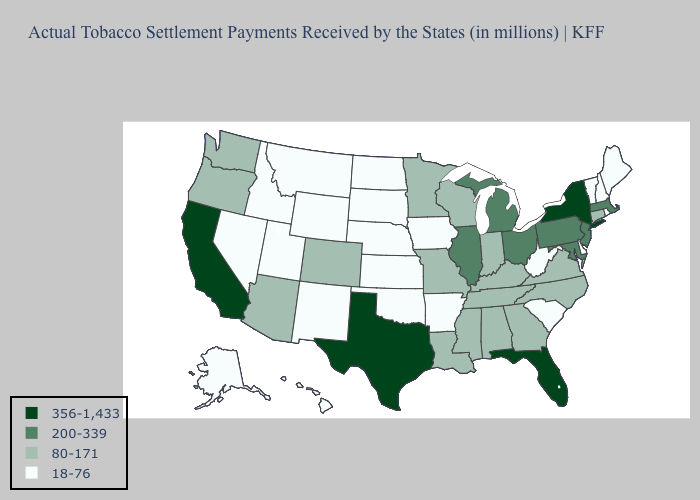How many symbols are there in the legend?
Be succinct. 4. Does Kansas have the lowest value in the USA?
Answer briefly. Yes. Name the states that have a value in the range 200-339?
Keep it brief. Illinois, Maryland, Massachusetts, Michigan, New Jersey, Ohio, Pennsylvania. Does the map have missing data?
Answer briefly. No. Among the states that border Oklahoma , which have the lowest value?
Answer briefly. Arkansas, Kansas, New Mexico. Does Maine have the lowest value in the USA?
Be succinct. Yes. Name the states that have a value in the range 18-76?
Quick response, please. Alaska, Arkansas, Delaware, Hawaii, Idaho, Iowa, Kansas, Maine, Montana, Nebraska, Nevada, New Hampshire, New Mexico, North Dakota, Oklahoma, Rhode Island, South Carolina, South Dakota, Utah, Vermont, West Virginia, Wyoming. What is the highest value in the USA?
Short answer required. 356-1,433. What is the value of Alabama?
Keep it brief. 80-171. What is the value of North Dakota?
Write a very short answer. 18-76. What is the highest value in states that border California?
Be succinct. 80-171. Does North Dakota have a higher value than North Carolina?
Keep it brief. No. Does Arkansas have a lower value than Alaska?
Give a very brief answer. No. Which states have the lowest value in the West?
Keep it brief. Alaska, Hawaii, Idaho, Montana, Nevada, New Mexico, Utah, Wyoming. Does South Carolina have a higher value than Kentucky?
Keep it brief. No. 